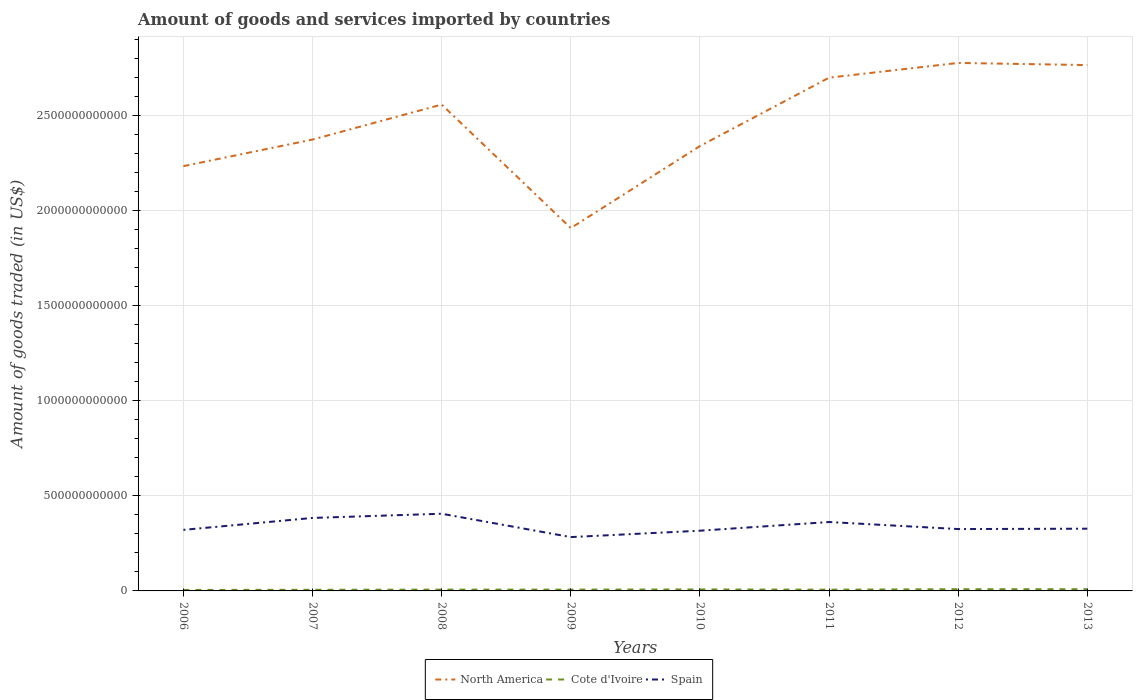Does the line corresponding to Cote d'Ivoire intersect with the line corresponding to Spain?
Make the answer very short. No. Is the number of lines equal to the number of legend labels?
Ensure brevity in your answer.  Yes. Across all years, what is the maximum total amount of goods and services imported in Cote d'Ivoire?
Offer a very short reply. 5.21e+09. What is the total total amount of goods and services imported in North America in the graph?
Keep it short and to the point. -4.32e+11. What is the difference between the highest and the second highest total amount of goods and services imported in Spain?
Your response must be concise. 1.23e+11. Is the total amount of goods and services imported in Spain strictly greater than the total amount of goods and services imported in Cote d'Ivoire over the years?
Offer a terse response. No. How many years are there in the graph?
Your response must be concise. 8. What is the difference between two consecutive major ticks on the Y-axis?
Keep it short and to the point. 5.00e+11. Does the graph contain any zero values?
Make the answer very short. No. Does the graph contain grids?
Ensure brevity in your answer.  Yes. Where does the legend appear in the graph?
Your answer should be compact. Bottom center. What is the title of the graph?
Provide a short and direct response. Amount of goods and services imported by countries. What is the label or title of the Y-axis?
Offer a terse response. Amount of goods traded (in US$). What is the Amount of goods traded (in US$) of North America in 2006?
Your answer should be very brief. 2.24e+12. What is the Amount of goods traded (in US$) in Cote d'Ivoire in 2006?
Make the answer very short. 5.21e+09. What is the Amount of goods traded (in US$) of Spain in 2006?
Ensure brevity in your answer.  3.21e+11. What is the Amount of goods traded (in US$) of North America in 2007?
Keep it short and to the point. 2.38e+12. What is the Amount of goods traded (in US$) in Cote d'Ivoire in 2007?
Ensure brevity in your answer.  5.94e+09. What is the Amount of goods traded (in US$) in Spain in 2007?
Keep it short and to the point. 3.84e+11. What is the Amount of goods traded (in US$) in North America in 2008?
Give a very brief answer. 2.56e+12. What is the Amount of goods traded (in US$) of Cote d'Ivoire in 2008?
Offer a very short reply. 6.88e+09. What is the Amount of goods traded (in US$) in Spain in 2008?
Your answer should be compact. 4.06e+11. What is the Amount of goods traded (in US$) in North America in 2009?
Offer a very short reply. 1.91e+12. What is the Amount of goods traded (in US$) in Cote d'Ivoire in 2009?
Offer a terse response. 6.91e+09. What is the Amount of goods traded (in US$) of Spain in 2009?
Make the answer very short. 2.83e+11. What is the Amount of goods traded (in US$) in North America in 2010?
Provide a short and direct response. 2.34e+12. What is the Amount of goods traded (in US$) of Cote d'Ivoire in 2010?
Provide a short and direct response. 7.79e+09. What is the Amount of goods traded (in US$) in Spain in 2010?
Provide a succinct answer. 3.17e+11. What is the Amount of goods traded (in US$) of North America in 2011?
Ensure brevity in your answer.  2.70e+12. What is the Amount of goods traded (in US$) of Cote d'Ivoire in 2011?
Provide a succinct answer. 6.67e+09. What is the Amount of goods traded (in US$) of Spain in 2011?
Make the answer very short. 3.63e+11. What is the Amount of goods traded (in US$) in North America in 2012?
Ensure brevity in your answer.  2.78e+12. What is the Amount of goods traded (in US$) in Cote d'Ivoire in 2012?
Your response must be concise. 9.06e+09. What is the Amount of goods traded (in US$) of Spain in 2012?
Make the answer very short. 3.26e+11. What is the Amount of goods traded (in US$) in North America in 2013?
Your answer should be compact. 2.77e+12. What is the Amount of goods traded (in US$) in Cote d'Ivoire in 2013?
Make the answer very short. 9.06e+09. What is the Amount of goods traded (in US$) of Spain in 2013?
Your answer should be compact. 3.28e+11. Across all years, what is the maximum Amount of goods traded (in US$) in North America?
Your answer should be compact. 2.78e+12. Across all years, what is the maximum Amount of goods traded (in US$) of Cote d'Ivoire?
Offer a very short reply. 9.06e+09. Across all years, what is the maximum Amount of goods traded (in US$) of Spain?
Offer a terse response. 4.06e+11. Across all years, what is the minimum Amount of goods traded (in US$) of North America?
Ensure brevity in your answer.  1.91e+12. Across all years, what is the minimum Amount of goods traded (in US$) in Cote d'Ivoire?
Keep it short and to the point. 5.21e+09. Across all years, what is the minimum Amount of goods traded (in US$) in Spain?
Offer a very short reply. 2.83e+11. What is the total Amount of goods traded (in US$) of North America in the graph?
Your response must be concise. 1.97e+13. What is the total Amount of goods traded (in US$) in Cote d'Ivoire in the graph?
Ensure brevity in your answer.  5.75e+1. What is the total Amount of goods traded (in US$) of Spain in the graph?
Provide a succinct answer. 2.73e+12. What is the difference between the Amount of goods traded (in US$) in North America in 2006 and that in 2007?
Provide a succinct answer. -1.40e+11. What is the difference between the Amount of goods traded (in US$) of Cote d'Ivoire in 2006 and that in 2007?
Your answer should be very brief. -7.28e+08. What is the difference between the Amount of goods traded (in US$) in Spain in 2006 and that in 2007?
Your response must be concise. -6.29e+1. What is the difference between the Amount of goods traded (in US$) of North America in 2006 and that in 2008?
Provide a short and direct response. -3.24e+11. What is the difference between the Amount of goods traded (in US$) in Cote d'Ivoire in 2006 and that in 2008?
Your answer should be very brief. -1.67e+09. What is the difference between the Amount of goods traded (in US$) in Spain in 2006 and that in 2008?
Provide a short and direct response. -8.49e+1. What is the difference between the Amount of goods traded (in US$) of North America in 2006 and that in 2009?
Ensure brevity in your answer.  3.26e+11. What is the difference between the Amount of goods traded (in US$) of Cote d'Ivoire in 2006 and that in 2009?
Provide a succinct answer. -1.70e+09. What is the difference between the Amount of goods traded (in US$) of Spain in 2006 and that in 2009?
Ensure brevity in your answer.  3.80e+1. What is the difference between the Amount of goods traded (in US$) of North America in 2006 and that in 2010?
Offer a terse response. -1.06e+11. What is the difference between the Amount of goods traded (in US$) in Cote d'Ivoire in 2006 and that in 2010?
Ensure brevity in your answer.  -2.58e+09. What is the difference between the Amount of goods traded (in US$) of Spain in 2006 and that in 2010?
Your answer should be very brief. 4.40e+09. What is the difference between the Amount of goods traded (in US$) of North America in 2006 and that in 2011?
Keep it short and to the point. -4.66e+11. What is the difference between the Amount of goods traded (in US$) in Cote d'Ivoire in 2006 and that in 2011?
Make the answer very short. -1.46e+09. What is the difference between the Amount of goods traded (in US$) in Spain in 2006 and that in 2011?
Your response must be concise. -4.13e+1. What is the difference between the Amount of goods traded (in US$) in North America in 2006 and that in 2012?
Give a very brief answer. -5.43e+11. What is the difference between the Amount of goods traded (in US$) in Cote d'Ivoire in 2006 and that in 2012?
Provide a short and direct response. -3.85e+09. What is the difference between the Amount of goods traded (in US$) in Spain in 2006 and that in 2012?
Provide a short and direct response. -4.22e+09. What is the difference between the Amount of goods traded (in US$) in North America in 2006 and that in 2013?
Your answer should be very brief. -5.32e+11. What is the difference between the Amount of goods traded (in US$) in Cote d'Ivoire in 2006 and that in 2013?
Your answer should be very brief. -3.85e+09. What is the difference between the Amount of goods traded (in US$) in Spain in 2006 and that in 2013?
Provide a short and direct response. -6.19e+09. What is the difference between the Amount of goods traded (in US$) in North America in 2007 and that in 2008?
Make the answer very short. -1.84e+11. What is the difference between the Amount of goods traded (in US$) in Cote d'Ivoire in 2007 and that in 2008?
Your response must be concise. -9.45e+08. What is the difference between the Amount of goods traded (in US$) in Spain in 2007 and that in 2008?
Offer a very short reply. -2.20e+1. What is the difference between the Amount of goods traded (in US$) in North America in 2007 and that in 2009?
Your answer should be very brief. 4.66e+11. What is the difference between the Amount of goods traded (in US$) in Cote d'Ivoire in 2007 and that in 2009?
Your answer should be compact. -9.74e+08. What is the difference between the Amount of goods traded (in US$) in Spain in 2007 and that in 2009?
Give a very brief answer. 1.01e+11. What is the difference between the Amount of goods traded (in US$) in North America in 2007 and that in 2010?
Your answer should be compact. 3.43e+1. What is the difference between the Amount of goods traded (in US$) of Cote d'Ivoire in 2007 and that in 2010?
Your answer should be very brief. -1.85e+09. What is the difference between the Amount of goods traded (in US$) of Spain in 2007 and that in 2010?
Give a very brief answer. 6.73e+1. What is the difference between the Amount of goods traded (in US$) in North America in 2007 and that in 2011?
Offer a very short reply. -3.26e+11. What is the difference between the Amount of goods traded (in US$) in Cote d'Ivoire in 2007 and that in 2011?
Keep it short and to the point. -7.30e+08. What is the difference between the Amount of goods traded (in US$) of Spain in 2007 and that in 2011?
Provide a succinct answer. 2.16e+1. What is the difference between the Amount of goods traded (in US$) in North America in 2007 and that in 2012?
Make the answer very short. -4.03e+11. What is the difference between the Amount of goods traded (in US$) in Cote d'Ivoire in 2007 and that in 2012?
Your response must be concise. -3.12e+09. What is the difference between the Amount of goods traded (in US$) in Spain in 2007 and that in 2012?
Offer a terse response. 5.86e+1. What is the difference between the Amount of goods traded (in US$) in North America in 2007 and that in 2013?
Offer a very short reply. -3.92e+11. What is the difference between the Amount of goods traded (in US$) in Cote d'Ivoire in 2007 and that in 2013?
Your answer should be compact. -3.12e+09. What is the difference between the Amount of goods traded (in US$) of Spain in 2007 and that in 2013?
Your answer should be compact. 5.67e+1. What is the difference between the Amount of goods traded (in US$) of North America in 2008 and that in 2009?
Your answer should be compact. 6.50e+11. What is the difference between the Amount of goods traded (in US$) of Cote d'Ivoire in 2008 and that in 2009?
Your answer should be compact. -2.90e+07. What is the difference between the Amount of goods traded (in US$) of Spain in 2008 and that in 2009?
Your answer should be compact. 1.23e+11. What is the difference between the Amount of goods traded (in US$) in North America in 2008 and that in 2010?
Give a very brief answer. 2.18e+11. What is the difference between the Amount of goods traded (in US$) of Cote d'Ivoire in 2008 and that in 2010?
Your response must be concise. -9.06e+08. What is the difference between the Amount of goods traded (in US$) of Spain in 2008 and that in 2010?
Ensure brevity in your answer.  8.93e+1. What is the difference between the Amount of goods traded (in US$) of North America in 2008 and that in 2011?
Provide a short and direct response. -1.42e+11. What is the difference between the Amount of goods traded (in US$) in Cote d'Ivoire in 2008 and that in 2011?
Make the answer very short. 2.16e+08. What is the difference between the Amount of goods traded (in US$) of Spain in 2008 and that in 2011?
Make the answer very short. 4.36e+1. What is the difference between the Amount of goods traded (in US$) of North America in 2008 and that in 2012?
Offer a terse response. -2.19e+11. What is the difference between the Amount of goods traded (in US$) in Cote d'Ivoire in 2008 and that in 2012?
Provide a short and direct response. -2.17e+09. What is the difference between the Amount of goods traded (in US$) of Spain in 2008 and that in 2012?
Give a very brief answer. 8.07e+1. What is the difference between the Amount of goods traded (in US$) of North America in 2008 and that in 2013?
Your response must be concise. -2.08e+11. What is the difference between the Amount of goods traded (in US$) in Cote d'Ivoire in 2008 and that in 2013?
Your answer should be compact. -2.17e+09. What is the difference between the Amount of goods traded (in US$) of Spain in 2008 and that in 2013?
Provide a short and direct response. 7.87e+1. What is the difference between the Amount of goods traded (in US$) of North America in 2009 and that in 2010?
Provide a succinct answer. -4.32e+11. What is the difference between the Amount of goods traded (in US$) in Cote d'Ivoire in 2009 and that in 2010?
Offer a terse response. -8.77e+08. What is the difference between the Amount of goods traded (in US$) in Spain in 2009 and that in 2010?
Ensure brevity in your answer.  -3.36e+1. What is the difference between the Amount of goods traded (in US$) of North America in 2009 and that in 2011?
Give a very brief answer. -7.92e+11. What is the difference between the Amount of goods traded (in US$) in Cote d'Ivoire in 2009 and that in 2011?
Offer a terse response. 2.45e+08. What is the difference between the Amount of goods traded (in US$) in Spain in 2009 and that in 2011?
Offer a very short reply. -7.93e+1. What is the difference between the Amount of goods traded (in US$) of North America in 2009 and that in 2012?
Provide a succinct answer. -8.69e+11. What is the difference between the Amount of goods traded (in US$) in Cote d'Ivoire in 2009 and that in 2012?
Give a very brief answer. -2.15e+09. What is the difference between the Amount of goods traded (in US$) in Spain in 2009 and that in 2012?
Give a very brief answer. -4.22e+1. What is the difference between the Amount of goods traded (in US$) of North America in 2009 and that in 2013?
Provide a succinct answer. -8.58e+11. What is the difference between the Amount of goods traded (in US$) of Cote d'Ivoire in 2009 and that in 2013?
Ensure brevity in your answer.  -2.14e+09. What is the difference between the Amount of goods traded (in US$) of Spain in 2009 and that in 2013?
Your answer should be very brief. -4.42e+1. What is the difference between the Amount of goods traded (in US$) in North America in 2010 and that in 2011?
Ensure brevity in your answer.  -3.60e+11. What is the difference between the Amount of goods traded (in US$) in Cote d'Ivoire in 2010 and that in 2011?
Keep it short and to the point. 1.12e+09. What is the difference between the Amount of goods traded (in US$) of Spain in 2010 and that in 2011?
Give a very brief answer. -4.57e+1. What is the difference between the Amount of goods traded (in US$) in North America in 2010 and that in 2012?
Make the answer very short. -4.38e+11. What is the difference between the Amount of goods traded (in US$) in Cote d'Ivoire in 2010 and that in 2012?
Provide a succinct answer. -1.27e+09. What is the difference between the Amount of goods traded (in US$) of Spain in 2010 and that in 2012?
Your answer should be compact. -8.63e+09. What is the difference between the Amount of goods traded (in US$) of North America in 2010 and that in 2013?
Ensure brevity in your answer.  -4.26e+11. What is the difference between the Amount of goods traded (in US$) of Cote d'Ivoire in 2010 and that in 2013?
Keep it short and to the point. -1.27e+09. What is the difference between the Amount of goods traded (in US$) of Spain in 2010 and that in 2013?
Keep it short and to the point. -1.06e+1. What is the difference between the Amount of goods traded (in US$) of North America in 2011 and that in 2012?
Keep it short and to the point. -7.76e+1. What is the difference between the Amount of goods traded (in US$) of Cote d'Ivoire in 2011 and that in 2012?
Ensure brevity in your answer.  -2.39e+09. What is the difference between the Amount of goods traded (in US$) in Spain in 2011 and that in 2012?
Keep it short and to the point. 3.71e+1. What is the difference between the Amount of goods traded (in US$) in North America in 2011 and that in 2013?
Provide a short and direct response. -6.63e+1. What is the difference between the Amount of goods traded (in US$) in Cote d'Ivoire in 2011 and that in 2013?
Offer a terse response. -2.39e+09. What is the difference between the Amount of goods traded (in US$) in Spain in 2011 and that in 2013?
Provide a succinct answer. 3.51e+1. What is the difference between the Amount of goods traded (in US$) of North America in 2012 and that in 2013?
Offer a very short reply. 1.13e+1. What is the difference between the Amount of goods traded (in US$) of Cote d'Ivoire in 2012 and that in 2013?
Offer a very short reply. 1.54e+06. What is the difference between the Amount of goods traded (in US$) of Spain in 2012 and that in 2013?
Offer a terse response. -1.96e+09. What is the difference between the Amount of goods traded (in US$) in North America in 2006 and the Amount of goods traded (in US$) in Cote d'Ivoire in 2007?
Keep it short and to the point. 2.23e+12. What is the difference between the Amount of goods traded (in US$) in North America in 2006 and the Amount of goods traded (in US$) in Spain in 2007?
Make the answer very short. 1.85e+12. What is the difference between the Amount of goods traded (in US$) of Cote d'Ivoire in 2006 and the Amount of goods traded (in US$) of Spain in 2007?
Offer a very short reply. -3.79e+11. What is the difference between the Amount of goods traded (in US$) in North America in 2006 and the Amount of goods traded (in US$) in Cote d'Ivoire in 2008?
Your answer should be very brief. 2.23e+12. What is the difference between the Amount of goods traded (in US$) of North America in 2006 and the Amount of goods traded (in US$) of Spain in 2008?
Keep it short and to the point. 1.83e+12. What is the difference between the Amount of goods traded (in US$) of Cote d'Ivoire in 2006 and the Amount of goods traded (in US$) of Spain in 2008?
Keep it short and to the point. -4.01e+11. What is the difference between the Amount of goods traded (in US$) in North America in 2006 and the Amount of goods traded (in US$) in Cote d'Ivoire in 2009?
Provide a succinct answer. 2.23e+12. What is the difference between the Amount of goods traded (in US$) of North America in 2006 and the Amount of goods traded (in US$) of Spain in 2009?
Keep it short and to the point. 1.95e+12. What is the difference between the Amount of goods traded (in US$) of Cote d'Ivoire in 2006 and the Amount of goods traded (in US$) of Spain in 2009?
Your answer should be very brief. -2.78e+11. What is the difference between the Amount of goods traded (in US$) of North America in 2006 and the Amount of goods traded (in US$) of Cote d'Ivoire in 2010?
Make the answer very short. 2.23e+12. What is the difference between the Amount of goods traded (in US$) in North America in 2006 and the Amount of goods traded (in US$) in Spain in 2010?
Your answer should be very brief. 1.92e+12. What is the difference between the Amount of goods traded (in US$) in Cote d'Ivoire in 2006 and the Amount of goods traded (in US$) in Spain in 2010?
Offer a very short reply. -3.12e+11. What is the difference between the Amount of goods traded (in US$) of North America in 2006 and the Amount of goods traded (in US$) of Cote d'Ivoire in 2011?
Provide a succinct answer. 2.23e+12. What is the difference between the Amount of goods traded (in US$) of North America in 2006 and the Amount of goods traded (in US$) of Spain in 2011?
Provide a short and direct response. 1.87e+12. What is the difference between the Amount of goods traded (in US$) of Cote d'Ivoire in 2006 and the Amount of goods traded (in US$) of Spain in 2011?
Make the answer very short. -3.57e+11. What is the difference between the Amount of goods traded (in US$) of North America in 2006 and the Amount of goods traded (in US$) of Cote d'Ivoire in 2012?
Make the answer very short. 2.23e+12. What is the difference between the Amount of goods traded (in US$) of North America in 2006 and the Amount of goods traded (in US$) of Spain in 2012?
Your answer should be very brief. 1.91e+12. What is the difference between the Amount of goods traded (in US$) in Cote d'Ivoire in 2006 and the Amount of goods traded (in US$) in Spain in 2012?
Your response must be concise. -3.20e+11. What is the difference between the Amount of goods traded (in US$) in North America in 2006 and the Amount of goods traded (in US$) in Cote d'Ivoire in 2013?
Your answer should be very brief. 2.23e+12. What is the difference between the Amount of goods traded (in US$) in North America in 2006 and the Amount of goods traded (in US$) in Spain in 2013?
Keep it short and to the point. 1.91e+12. What is the difference between the Amount of goods traded (in US$) in Cote d'Ivoire in 2006 and the Amount of goods traded (in US$) in Spain in 2013?
Offer a very short reply. -3.22e+11. What is the difference between the Amount of goods traded (in US$) of North America in 2007 and the Amount of goods traded (in US$) of Cote d'Ivoire in 2008?
Provide a short and direct response. 2.37e+12. What is the difference between the Amount of goods traded (in US$) in North America in 2007 and the Amount of goods traded (in US$) in Spain in 2008?
Provide a succinct answer. 1.97e+12. What is the difference between the Amount of goods traded (in US$) of Cote d'Ivoire in 2007 and the Amount of goods traded (in US$) of Spain in 2008?
Your answer should be compact. -4.00e+11. What is the difference between the Amount of goods traded (in US$) in North America in 2007 and the Amount of goods traded (in US$) in Cote d'Ivoire in 2009?
Offer a very short reply. 2.37e+12. What is the difference between the Amount of goods traded (in US$) of North America in 2007 and the Amount of goods traded (in US$) of Spain in 2009?
Provide a succinct answer. 2.09e+12. What is the difference between the Amount of goods traded (in US$) of Cote d'Ivoire in 2007 and the Amount of goods traded (in US$) of Spain in 2009?
Ensure brevity in your answer.  -2.77e+11. What is the difference between the Amount of goods traded (in US$) of North America in 2007 and the Amount of goods traded (in US$) of Cote d'Ivoire in 2010?
Give a very brief answer. 2.37e+12. What is the difference between the Amount of goods traded (in US$) of North America in 2007 and the Amount of goods traded (in US$) of Spain in 2010?
Your answer should be very brief. 2.06e+12. What is the difference between the Amount of goods traded (in US$) in Cote d'Ivoire in 2007 and the Amount of goods traded (in US$) in Spain in 2010?
Provide a short and direct response. -3.11e+11. What is the difference between the Amount of goods traded (in US$) of North America in 2007 and the Amount of goods traded (in US$) of Cote d'Ivoire in 2011?
Make the answer very short. 2.37e+12. What is the difference between the Amount of goods traded (in US$) of North America in 2007 and the Amount of goods traded (in US$) of Spain in 2011?
Keep it short and to the point. 2.01e+12. What is the difference between the Amount of goods traded (in US$) of Cote d'Ivoire in 2007 and the Amount of goods traded (in US$) of Spain in 2011?
Make the answer very short. -3.57e+11. What is the difference between the Amount of goods traded (in US$) of North America in 2007 and the Amount of goods traded (in US$) of Cote d'Ivoire in 2012?
Your response must be concise. 2.37e+12. What is the difference between the Amount of goods traded (in US$) in North America in 2007 and the Amount of goods traded (in US$) in Spain in 2012?
Ensure brevity in your answer.  2.05e+12. What is the difference between the Amount of goods traded (in US$) of Cote d'Ivoire in 2007 and the Amount of goods traded (in US$) of Spain in 2012?
Make the answer very short. -3.20e+11. What is the difference between the Amount of goods traded (in US$) in North America in 2007 and the Amount of goods traded (in US$) in Cote d'Ivoire in 2013?
Keep it short and to the point. 2.37e+12. What is the difference between the Amount of goods traded (in US$) of North America in 2007 and the Amount of goods traded (in US$) of Spain in 2013?
Provide a short and direct response. 2.05e+12. What is the difference between the Amount of goods traded (in US$) of Cote d'Ivoire in 2007 and the Amount of goods traded (in US$) of Spain in 2013?
Offer a very short reply. -3.22e+11. What is the difference between the Amount of goods traded (in US$) in North America in 2008 and the Amount of goods traded (in US$) in Cote d'Ivoire in 2009?
Your answer should be very brief. 2.55e+12. What is the difference between the Amount of goods traded (in US$) in North America in 2008 and the Amount of goods traded (in US$) in Spain in 2009?
Your answer should be very brief. 2.28e+12. What is the difference between the Amount of goods traded (in US$) in Cote d'Ivoire in 2008 and the Amount of goods traded (in US$) in Spain in 2009?
Your answer should be very brief. -2.77e+11. What is the difference between the Amount of goods traded (in US$) in North America in 2008 and the Amount of goods traded (in US$) in Cote d'Ivoire in 2010?
Provide a short and direct response. 2.55e+12. What is the difference between the Amount of goods traded (in US$) of North America in 2008 and the Amount of goods traded (in US$) of Spain in 2010?
Give a very brief answer. 2.24e+12. What is the difference between the Amount of goods traded (in US$) of Cote d'Ivoire in 2008 and the Amount of goods traded (in US$) of Spain in 2010?
Provide a succinct answer. -3.10e+11. What is the difference between the Amount of goods traded (in US$) in North America in 2008 and the Amount of goods traded (in US$) in Cote d'Ivoire in 2011?
Your answer should be compact. 2.55e+12. What is the difference between the Amount of goods traded (in US$) in North America in 2008 and the Amount of goods traded (in US$) in Spain in 2011?
Keep it short and to the point. 2.20e+12. What is the difference between the Amount of goods traded (in US$) of Cote d'Ivoire in 2008 and the Amount of goods traded (in US$) of Spain in 2011?
Offer a very short reply. -3.56e+11. What is the difference between the Amount of goods traded (in US$) of North America in 2008 and the Amount of goods traded (in US$) of Cote d'Ivoire in 2012?
Offer a terse response. 2.55e+12. What is the difference between the Amount of goods traded (in US$) of North America in 2008 and the Amount of goods traded (in US$) of Spain in 2012?
Ensure brevity in your answer.  2.23e+12. What is the difference between the Amount of goods traded (in US$) of Cote d'Ivoire in 2008 and the Amount of goods traded (in US$) of Spain in 2012?
Your answer should be compact. -3.19e+11. What is the difference between the Amount of goods traded (in US$) of North America in 2008 and the Amount of goods traded (in US$) of Cote d'Ivoire in 2013?
Offer a very short reply. 2.55e+12. What is the difference between the Amount of goods traded (in US$) of North America in 2008 and the Amount of goods traded (in US$) of Spain in 2013?
Make the answer very short. 2.23e+12. What is the difference between the Amount of goods traded (in US$) of Cote d'Ivoire in 2008 and the Amount of goods traded (in US$) of Spain in 2013?
Give a very brief answer. -3.21e+11. What is the difference between the Amount of goods traded (in US$) of North America in 2009 and the Amount of goods traded (in US$) of Cote d'Ivoire in 2010?
Ensure brevity in your answer.  1.90e+12. What is the difference between the Amount of goods traded (in US$) in North America in 2009 and the Amount of goods traded (in US$) in Spain in 2010?
Provide a succinct answer. 1.59e+12. What is the difference between the Amount of goods traded (in US$) in Cote d'Ivoire in 2009 and the Amount of goods traded (in US$) in Spain in 2010?
Give a very brief answer. -3.10e+11. What is the difference between the Amount of goods traded (in US$) of North America in 2009 and the Amount of goods traded (in US$) of Cote d'Ivoire in 2011?
Your answer should be compact. 1.90e+12. What is the difference between the Amount of goods traded (in US$) in North America in 2009 and the Amount of goods traded (in US$) in Spain in 2011?
Provide a succinct answer. 1.55e+12. What is the difference between the Amount of goods traded (in US$) in Cote d'Ivoire in 2009 and the Amount of goods traded (in US$) in Spain in 2011?
Provide a short and direct response. -3.56e+11. What is the difference between the Amount of goods traded (in US$) of North America in 2009 and the Amount of goods traded (in US$) of Cote d'Ivoire in 2012?
Provide a succinct answer. 1.90e+12. What is the difference between the Amount of goods traded (in US$) of North America in 2009 and the Amount of goods traded (in US$) of Spain in 2012?
Your answer should be very brief. 1.58e+12. What is the difference between the Amount of goods traded (in US$) in Cote d'Ivoire in 2009 and the Amount of goods traded (in US$) in Spain in 2012?
Make the answer very short. -3.19e+11. What is the difference between the Amount of goods traded (in US$) of North America in 2009 and the Amount of goods traded (in US$) of Cote d'Ivoire in 2013?
Your answer should be compact. 1.90e+12. What is the difference between the Amount of goods traded (in US$) in North America in 2009 and the Amount of goods traded (in US$) in Spain in 2013?
Make the answer very short. 1.58e+12. What is the difference between the Amount of goods traded (in US$) in Cote d'Ivoire in 2009 and the Amount of goods traded (in US$) in Spain in 2013?
Your response must be concise. -3.21e+11. What is the difference between the Amount of goods traded (in US$) of North America in 2010 and the Amount of goods traded (in US$) of Cote d'Ivoire in 2011?
Ensure brevity in your answer.  2.33e+12. What is the difference between the Amount of goods traded (in US$) of North America in 2010 and the Amount of goods traded (in US$) of Spain in 2011?
Provide a succinct answer. 1.98e+12. What is the difference between the Amount of goods traded (in US$) in Cote d'Ivoire in 2010 and the Amount of goods traded (in US$) in Spain in 2011?
Ensure brevity in your answer.  -3.55e+11. What is the difference between the Amount of goods traded (in US$) of North America in 2010 and the Amount of goods traded (in US$) of Cote d'Ivoire in 2012?
Give a very brief answer. 2.33e+12. What is the difference between the Amount of goods traded (in US$) of North America in 2010 and the Amount of goods traded (in US$) of Spain in 2012?
Give a very brief answer. 2.02e+12. What is the difference between the Amount of goods traded (in US$) of Cote d'Ivoire in 2010 and the Amount of goods traded (in US$) of Spain in 2012?
Your answer should be compact. -3.18e+11. What is the difference between the Amount of goods traded (in US$) of North America in 2010 and the Amount of goods traded (in US$) of Cote d'Ivoire in 2013?
Keep it short and to the point. 2.33e+12. What is the difference between the Amount of goods traded (in US$) of North America in 2010 and the Amount of goods traded (in US$) of Spain in 2013?
Offer a very short reply. 2.01e+12. What is the difference between the Amount of goods traded (in US$) in Cote d'Ivoire in 2010 and the Amount of goods traded (in US$) in Spain in 2013?
Provide a short and direct response. -3.20e+11. What is the difference between the Amount of goods traded (in US$) in North America in 2011 and the Amount of goods traded (in US$) in Cote d'Ivoire in 2012?
Give a very brief answer. 2.69e+12. What is the difference between the Amount of goods traded (in US$) of North America in 2011 and the Amount of goods traded (in US$) of Spain in 2012?
Keep it short and to the point. 2.38e+12. What is the difference between the Amount of goods traded (in US$) of Cote d'Ivoire in 2011 and the Amount of goods traded (in US$) of Spain in 2012?
Provide a short and direct response. -3.19e+11. What is the difference between the Amount of goods traded (in US$) in North America in 2011 and the Amount of goods traded (in US$) in Cote d'Ivoire in 2013?
Give a very brief answer. 2.69e+12. What is the difference between the Amount of goods traded (in US$) in North America in 2011 and the Amount of goods traded (in US$) in Spain in 2013?
Ensure brevity in your answer.  2.37e+12. What is the difference between the Amount of goods traded (in US$) of Cote d'Ivoire in 2011 and the Amount of goods traded (in US$) of Spain in 2013?
Keep it short and to the point. -3.21e+11. What is the difference between the Amount of goods traded (in US$) of North America in 2012 and the Amount of goods traded (in US$) of Cote d'Ivoire in 2013?
Offer a very short reply. 2.77e+12. What is the difference between the Amount of goods traded (in US$) in North America in 2012 and the Amount of goods traded (in US$) in Spain in 2013?
Make the answer very short. 2.45e+12. What is the difference between the Amount of goods traded (in US$) in Cote d'Ivoire in 2012 and the Amount of goods traded (in US$) in Spain in 2013?
Your response must be concise. -3.19e+11. What is the average Amount of goods traded (in US$) of North America per year?
Provide a short and direct response. 2.46e+12. What is the average Amount of goods traded (in US$) in Cote d'Ivoire per year?
Your answer should be compact. 7.19e+09. What is the average Amount of goods traded (in US$) of Spain per year?
Offer a terse response. 3.41e+11. In the year 2006, what is the difference between the Amount of goods traded (in US$) of North America and Amount of goods traded (in US$) of Cote d'Ivoire?
Keep it short and to the point. 2.23e+12. In the year 2006, what is the difference between the Amount of goods traded (in US$) of North America and Amount of goods traded (in US$) of Spain?
Keep it short and to the point. 1.91e+12. In the year 2006, what is the difference between the Amount of goods traded (in US$) of Cote d'Ivoire and Amount of goods traded (in US$) of Spain?
Provide a succinct answer. -3.16e+11. In the year 2007, what is the difference between the Amount of goods traded (in US$) in North America and Amount of goods traded (in US$) in Cote d'Ivoire?
Provide a short and direct response. 2.37e+12. In the year 2007, what is the difference between the Amount of goods traded (in US$) in North America and Amount of goods traded (in US$) in Spain?
Offer a terse response. 1.99e+12. In the year 2007, what is the difference between the Amount of goods traded (in US$) of Cote d'Ivoire and Amount of goods traded (in US$) of Spain?
Give a very brief answer. -3.78e+11. In the year 2008, what is the difference between the Amount of goods traded (in US$) of North America and Amount of goods traded (in US$) of Cote d'Ivoire?
Ensure brevity in your answer.  2.55e+12. In the year 2008, what is the difference between the Amount of goods traded (in US$) in North America and Amount of goods traded (in US$) in Spain?
Your answer should be very brief. 2.15e+12. In the year 2008, what is the difference between the Amount of goods traded (in US$) in Cote d'Ivoire and Amount of goods traded (in US$) in Spain?
Make the answer very short. -3.99e+11. In the year 2009, what is the difference between the Amount of goods traded (in US$) of North America and Amount of goods traded (in US$) of Cote d'Ivoire?
Ensure brevity in your answer.  1.90e+12. In the year 2009, what is the difference between the Amount of goods traded (in US$) of North America and Amount of goods traded (in US$) of Spain?
Offer a very short reply. 1.63e+12. In the year 2009, what is the difference between the Amount of goods traded (in US$) in Cote d'Ivoire and Amount of goods traded (in US$) in Spain?
Your response must be concise. -2.76e+11. In the year 2010, what is the difference between the Amount of goods traded (in US$) of North America and Amount of goods traded (in US$) of Cote d'Ivoire?
Provide a succinct answer. 2.33e+12. In the year 2010, what is the difference between the Amount of goods traded (in US$) in North America and Amount of goods traded (in US$) in Spain?
Give a very brief answer. 2.02e+12. In the year 2010, what is the difference between the Amount of goods traded (in US$) in Cote d'Ivoire and Amount of goods traded (in US$) in Spain?
Your answer should be very brief. -3.09e+11. In the year 2011, what is the difference between the Amount of goods traded (in US$) in North America and Amount of goods traded (in US$) in Cote d'Ivoire?
Your response must be concise. 2.70e+12. In the year 2011, what is the difference between the Amount of goods traded (in US$) of North America and Amount of goods traded (in US$) of Spain?
Your response must be concise. 2.34e+12. In the year 2011, what is the difference between the Amount of goods traded (in US$) in Cote d'Ivoire and Amount of goods traded (in US$) in Spain?
Provide a succinct answer. -3.56e+11. In the year 2012, what is the difference between the Amount of goods traded (in US$) in North America and Amount of goods traded (in US$) in Cote d'Ivoire?
Your response must be concise. 2.77e+12. In the year 2012, what is the difference between the Amount of goods traded (in US$) in North America and Amount of goods traded (in US$) in Spain?
Your response must be concise. 2.45e+12. In the year 2012, what is the difference between the Amount of goods traded (in US$) in Cote d'Ivoire and Amount of goods traded (in US$) in Spain?
Give a very brief answer. -3.17e+11. In the year 2013, what is the difference between the Amount of goods traded (in US$) in North America and Amount of goods traded (in US$) in Cote d'Ivoire?
Offer a terse response. 2.76e+12. In the year 2013, what is the difference between the Amount of goods traded (in US$) in North America and Amount of goods traded (in US$) in Spain?
Your answer should be compact. 2.44e+12. In the year 2013, what is the difference between the Amount of goods traded (in US$) in Cote d'Ivoire and Amount of goods traded (in US$) in Spain?
Your answer should be very brief. -3.19e+11. What is the ratio of the Amount of goods traded (in US$) of North America in 2006 to that in 2007?
Make the answer very short. 0.94. What is the ratio of the Amount of goods traded (in US$) of Cote d'Ivoire in 2006 to that in 2007?
Ensure brevity in your answer.  0.88. What is the ratio of the Amount of goods traded (in US$) of Spain in 2006 to that in 2007?
Offer a terse response. 0.84. What is the ratio of the Amount of goods traded (in US$) of North America in 2006 to that in 2008?
Make the answer very short. 0.87. What is the ratio of the Amount of goods traded (in US$) in Cote d'Ivoire in 2006 to that in 2008?
Provide a short and direct response. 0.76. What is the ratio of the Amount of goods traded (in US$) in Spain in 2006 to that in 2008?
Provide a short and direct response. 0.79. What is the ratio of the Amount of goods traded (in US$) in North America in 2006 to that in 2009?
Give a very brief answer. 1.17. What is the ratio of the Amount of goods traded (in US$) of Cote d'Ivoire in 2006 to that in 2009?
Your response must be concise. 0.75. What is the ratio of the Amount of goods traded (in US$) in Spain in 2006 to that in 2009?
Ensure brevity in your answer.  1.13. What is the ratio of the Amount of goods traded (in US$) in North America in 2006 to that in 2010?
Your answer should be compact. 0.95. What is the ratio of the Amount of goods traded (in US$) in Cote d'Ivoire in 2006 to that in 2010?
Give a very brief answer. 0.67. What is the ratio of the Amount of goods traded (in US$) of Spain in 2006 to that in 2010?
Keep it short and to the point. 1.01. What is the ratio of the Amount of goods traded (in US$) of North America in 2006 to that in 2011?
Offer a terse response. 0.83. What is the ratio of the Amount of goods traded (in US$) in Cote d'Ivoire in 2006 to that in 2011?
Offer a very short reply. 0.78. What is the ratio of the Amount of goods traded (in US$) in Spain in 2006 to that in 2011?
Provide a succinct answer. 0.89. What is the ratio of the Amount of goods traded (in US$) in North America in 2006 to that in 2012?
Provide a short and direct response. 0.8. What is the ratio of the Amount of goods traded (in US$) of Cote d'Ivoire in 2006 to that in 2012?
Give a very brief answer. 0.58. What is the ratio of the Amount of goods traded (in US$) in Spain in 2006 to that in 2012?
Provide a short and direct response. 0.99. What is the ratio of the Amount of goods traded (in US$) of North America in 2006 to that in 2013?
Keep it short and to the point. 0.81. What is the ratio of the Amount of goods traded (in US$) of Cote d'Ivoire in 2006 to that in 2013?
Give a very brief answer. 0.58. What is the ratio of the Amount of goods traded (in US$) in Spain in 2006 to that in 2013?
Provide a succinct answer. 0.98. What is the ratio of the Amount of goods traded (in US$) in North America in 2007 to that in 2008?
Keep it short and to the point. 0.93. What is the ratio of the Amount of goods traded (in US$) of Cote d'Ivoire in 2007 to that in 2008?
Provide a short and direct response. 0.86. What is the ratio of the Amount of goods traded (in US$) in Spain in 2007 to that in 2008?
Offer a terse response. 0.95. What is the ratio of the Amount of goods traded (in US$) of North America in 2007 to that in 2009?
Keep it short and to the point. 1.24. What is the ratio of the Amount of goods traded (in US$) in Cote d'Ivoire in 2007 to that in 2009?
Your response must be concise. 0.86. What is the ratio of the Amount of goods traded (in US$) in Spain in 2007 to that in 2009?
Give a very brief answer. 1.36. What is the ratio of the Amount of goods traded (in US$) of North America in 2007 to that in 2010?
Offer a terse response. 1.01. What is the ratio of the Amount of goods traded (in US$) of Cote d'Ivoire in 2007 to that in 2010?
Your response must be concise. 0.76. What is the ratio of the Amount of goods traded (in US$) in Spain in 2007 to that in 2010?
Ensure brevity in your answer.  1.21. What is the ratio of the Amount of goods traded (in US$) of North America in 2007 to that in 2011?
Offer a very short reply. 0.88. What is the ratio of the Amount of goods traded (in US$) of Cote d'Ivoire in 2007 to that in 2011?
Your answer should be very brief. 0.89. What is the ratio of the Amount of goods traded (in US$) of Spain in 2007 to that in 2011?
Your answer should be very brief. 1.06. What is the ratio of the Amount of goods traded (in US$) of North America in 2007 to that in 2012?
Offer a terse response. 0.85. What is the ratio of the Amount of goods traded (in US$) of Cote d'Ivoire in 2007 to that in 2012?
Your response must be concise. 0.66. What is the ratio of the Amount of goods traded (in US$) in Spain in 2007 to that in 2012?
Ensure brevity in your answer.  1.18. What is the ratio of the Amount of goods traded (in US$) of North America in 2007 to that in 2013?
Offer a terse response. 0.86. What is the ratio of the Amount of goods traded (in US$) of Cote d'Ivoire in 2007 to that in 2013?
Offer a very short reply. 0.66. What is the ratio of the Amount of goods traded (in US$) of Spain in 2007 to that in 2013?
Offer a very short reply. 1.17. What is the ratio of the Amount of goods traded (in US$) of North America in 2008 to that in 2009?
Make the answer very short. 1.34. What is the ratio of the Amount of goods traded (in US$) in Cote d'Ivoire in 2008 to that in 2009?
Offer a terse response. 1. What is the ratio of the Amount of goods traded (in US$) of Spain in 2008 to that in 2009?
Provide a short and direct response. 1.43. What is the ratio of the Amount of goods traded (in US$) in North America in 2008 to that in 2010?
Provide a short and direct response. 1.09. What is the ratio of the Amount of goods traded (in US$) of Cote d'Ivoire in 2008 to that in 2010?
Offer a very short reply. 0.88. What is the ratio of the Amount of goods traded (in US$) in Spain in 2008 to that in 2010?
Ensure brevity in your answer.  1.28. What is the ratio of the Amount of goods traded (in US$) of North America in 2008 to that in 2011?
Keep it short and to the point. 0.95. What is the ratio of the Amount of goods traded (in US$) of Cote d'Ivoire in 2008 to that in 2011?
Provide a short and direct response. 1.03. What is the ratio of the Amount of goods traded (in US$) in Spain in 2008 to that in 2011?
Offer a very short reply. 1.12. What is the ratio of the Amount of goods traded (in US$) of North America in 2008 to that in 2012?
Give a very brief answer. 0.92. What is the ratio of the Amount of goods traded (in US$) in Cote d'Ivoire in 2008 to that in 2012?
Offer a very short reply. 0.76. What is the ratio of the Amount of goods traded (in US$) in Spain in 2008 to that in 2012?
Offer a terse response. 1.25. What is the ratio of the Amount of goods traded (in US$) of North America in 2008 to that in 2013?
Your response must be concise. 0.92. What is the ratio of the Amount of goods traded (in US$) of Cote d'Ivoire in 2008 to that in 2013?
Your answer should be very brief. 0.76. What is the ratio of the Amount of goods traded (in US$) of Spain in 2008 to that in 2013?
Provide a succinct answer. 1.24. What is the ratio of the Amount of goods traded (in US$) in North America in 2009 to that in 2010?
Offer a terse response. 0.82. What is the ratio of the Amount of goods traded (in US$) of Cote d'Ivoire in 2009 to that in 2010?
Your answer should be compact. 0.89. What is the ratio of the Amount of goods traded (in US$) of Spain in 2009 to that in 2010?
Provide a succinct answer. 0.89. What is the ratio of the Amount of goods traded (in US$) of North America in 2009 to that in 2011?
Keep it short and to the point. 0.71. What is the ratio of the Amount of goods traded (in US$) of Cote d'Ivoire in 2009 to that in 2011?
Offer a terse response. 1.04. What is the ratio of the Amount of goods traded (in US$) of Spain in 2009 to that in 2011?
Keep it short and to the point. 0.78. What is the ratio of the Amount of goods traded (in US$) in North America in 2009 to that in 2012?
Keep it short and to the point. 0.69. What is the ratio of the Amount of goods traded (in US$) of Cote d'Ivoire in 2009 to that in 2012?
Your answer should be compact. 0.76. What is the ratio of the Amount of goods traded (in US$) in Spain in 2009 to that in 2012?
Provide a short and direct response. 0.87. What is the ratio of the Amount of goods traded (in US$) in North America in 2009 to that in 2013?
Your answer should be very brief. 0.69. What is the ratio of the Amount of goods traded (in US$) in Cote d'Ivoire in 2009 to that in 2013?
Your answer should be very brief. 0.76. What is the ratio of the Amount of goods traded (in US$) in Spain in 2009 to that in 2013?
Offer a terse response. 0.87. What is the ratio of the Amount of goods traded (in US$) of North America in 2010 to that in 2011?
Offer a very short reply. 0.87. What is the ratio of the Amount of goods traded (in US$) in Cote d'Ivoire in 2010 to that in 2011?
Offer a very short reply. 1.17. What is the ratio of the Amount of goods traded (in US$) of Spain in 2010 to that in 2011?
Your response must be concise. 0.87. What is the ratio of the Amount of goods traded (in US$) of North America in 2010 to that in 2012?
Give a very brief answer. 0.84. What is the ratio of the Amount of goods traded (in US$) of Cote d'Ivoire in 2010 to that in 2012?
Give a very brief answer. 0.86. What is the ratio of the Amount of goods traded (in US$) in Spain in 2010 to that in 2012?
Your answer should be very brief. 0.97. What is the ratio of the Amount of goods traded (in US$) of North America in 2010 to that in 2013?
Ensure brevity in your answer.  0.85. What is the ratio of the Amount of goods traded (in US$) of Cote d'Ivoire in 2010 to that in 2013?
Offer a very short reply. 0.86. What is the ratio of the Amount of goods traded (in US$) of Spain in 2010 to that in 2013?
Keep it short and to the point. 0.97. What is the ratio of the Amount of goods traded (in US$) of North America in 2011 to that in 2012?
Give a very brief answer. 0.97. What is the ratio of the Amount of goods traded (in US$) in Cote d'Ivoire in 2011 to that in 2012?
Offer a very short reply. 0.74. What is the ratio of the Amount of goods traded (in US$) in Spain in 2011 to that in 2012?
Your answer should be compact. 1.11. What is the ratio of the Amount of goods traded (in US$) in North America in 2011 to that in 2013?
Your response must be concise. 0.98. What is the ratio of the Amount of goods traded (in US$) of Cote d'Ivoire in 2011 to that in 2013?
Your answer should be very brief. 0.74. What is the ratio of the Amount of goods traded (in US$) in Spain in 2011 to that in 2013?
Give a very brief answer. 1.11. What is the ratio of the Amount of goods traded (in US$) in North America in 2012 to that in 2013?
Your answer should be compact. 1. What is the ratio of the Amount of goods traded (in US$) of Cote d'Ivoire in 2012 to that in 2013?
Keep it short and to the point. 1. What is the ratio of the Amount of goods traded (in US$) in Spain in 2012 to that in 2013?
Give a very brief answer. 0.99. What is the difference between the highest and the second highest Amount of goods traded (in US$) of North America?
Provide a succinct answer. 1.13e+1. What is the difference between the highest and the second highest Amount of goods traded (in US$) in Cote d'Ivoire?
Your answer should be compact. 1.54e+06. What is the difference between the highest and the second highest Amount of goods traded (in US$) in Spain?
Provide a short and direct response. 2.20e+1. What is the difference between the highest and the lowest Amount of goods traded (in US$) in North America?
Make the answer very short. 8.69e+11. What is the difference between the highest and the lowest Amount of goods traded (in US$) in Cote d'Ivoire?
Your response must be concise. 3.85e+09. What is the difference between the highest and the lowest Amount of goods traded (in US$) in Spain?
Your answer should be compact. 1.23e+11. 